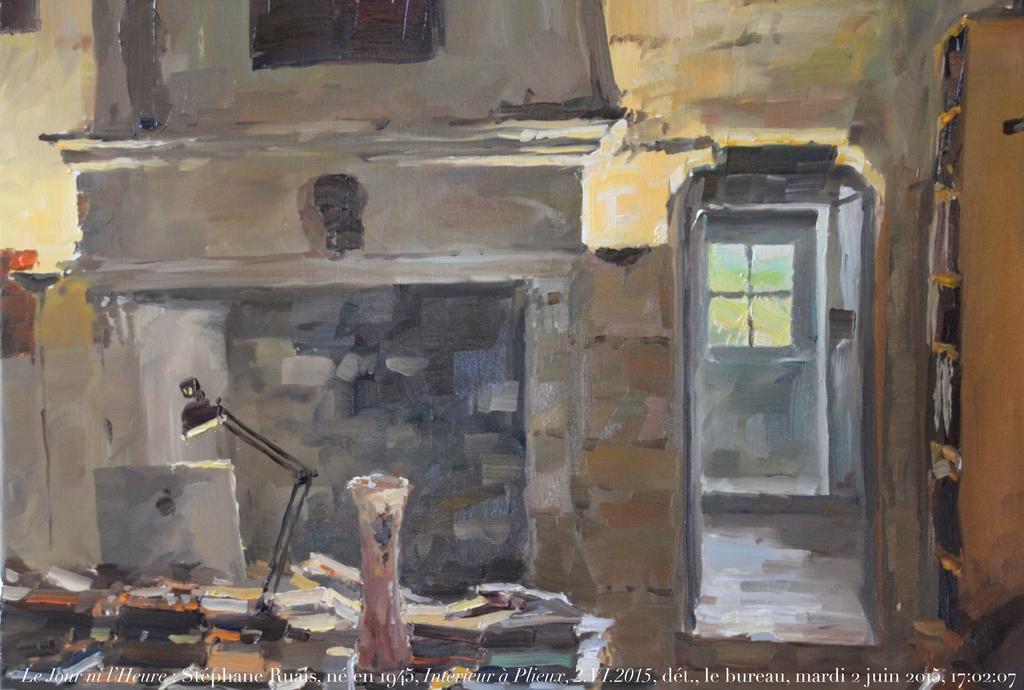What's the color of the text going across the bottom?
Your answer should be compact. White. 